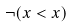Convert formula to latex. <formula><loc_0><loc_0><loc_500><loc_500>\neg ( x < x )</formula> 